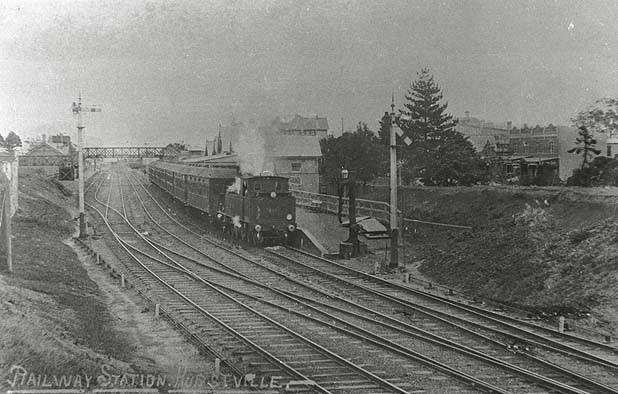Is this train new?
Short answer required. No. What is coming out of the train?
Answer briefly. Smoke. Are these train tracks made out of metal?
Keep it brief. Yes. Why are there many railroads on the ground?
Write a very short answer. Different railroad lines converge there. 